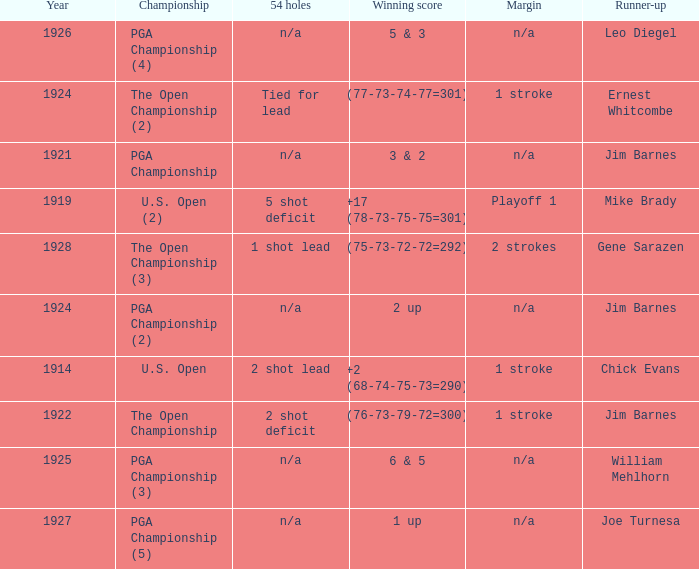WHAT YEAR WAS IT WHEN THE SCORE WAS 3 & 2? 1921.0. 